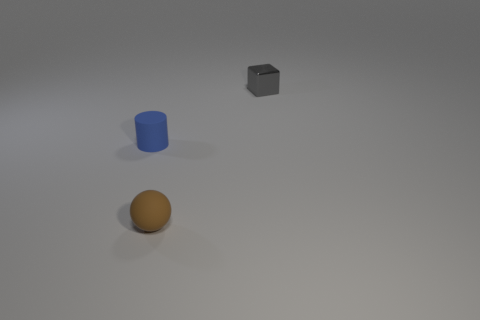Add 3 cyan shiny cylinders. How many objects exist? 6 Subtract all spheres. How many objects are left? 2 Add 3 tiny gray cubes. How many tiny gray cubes exist? 4 Subtract 0 cyan cubes. How many objects are left? 3 Subtract all big green rubber cubes. Subtract all gray objects. How many objects are left? 2 Add 2 tiny brown matte things. How many tiny brown matte things are left? 3 